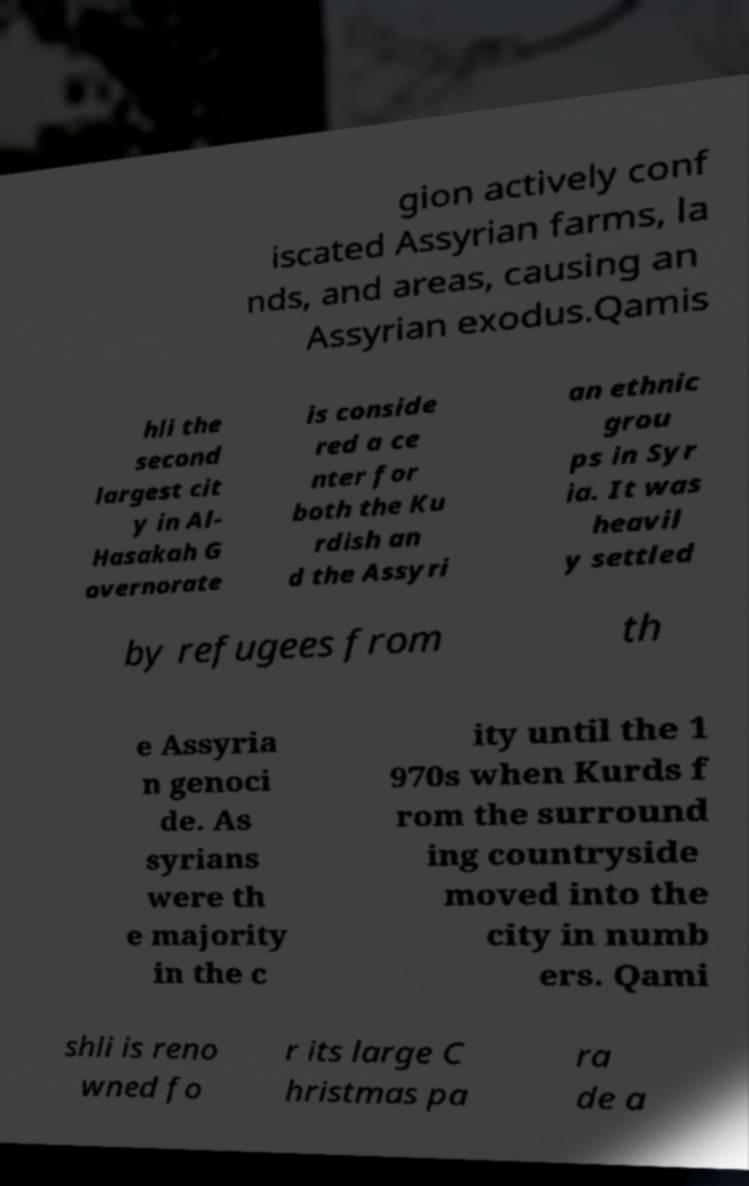What messages or text are displayed in this image? I need them in a readable, typed format. gion actively conf iscated Assyrian farms, la nds, and areas, causing an Assyrian exodus.Qamis hli the second largest cit y in Al- Hasakah G overnorate is conside red a ce nter for both the Ku rdish an d the Assyri an ethnic grou ps in Syr ia. It was heavil y settled by refugees from th e Assyria n genoci de. As syrians were th e majority in the c ity until the 1 970s when Kurds f rom the surround ing countryside moved into the city in numb ers. Qami shli is reno wned fo r its large C hristmas pa ra de a 